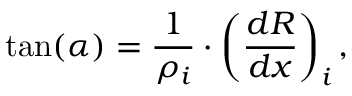<formula> <loc_0><loc_0><loc_500><loc_500>\tan ( \alpha ) = \frac { 1 } { \rho _ { i } } \cdot \left ( \frac { d R } { d x } \right ) _ { i } ,</formula> 